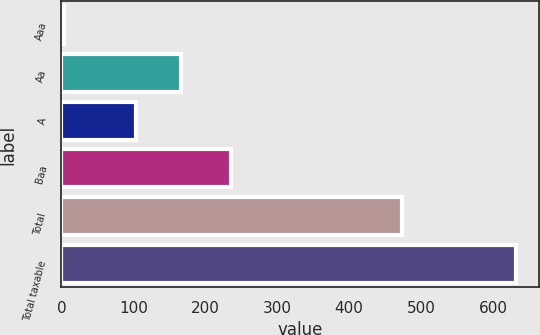<chart> <loc_0><loc_0><loc_500><loc_500><bar_chart><fcel>Aaa<fcel>Aa<fcel>A<fcel>Baa<fcel>Total<fcel>Total taxable<nl><fcel>3<fcel>165.9<fcel>103<fcel>236<fcel>474<fcel>632<nl></chart> 